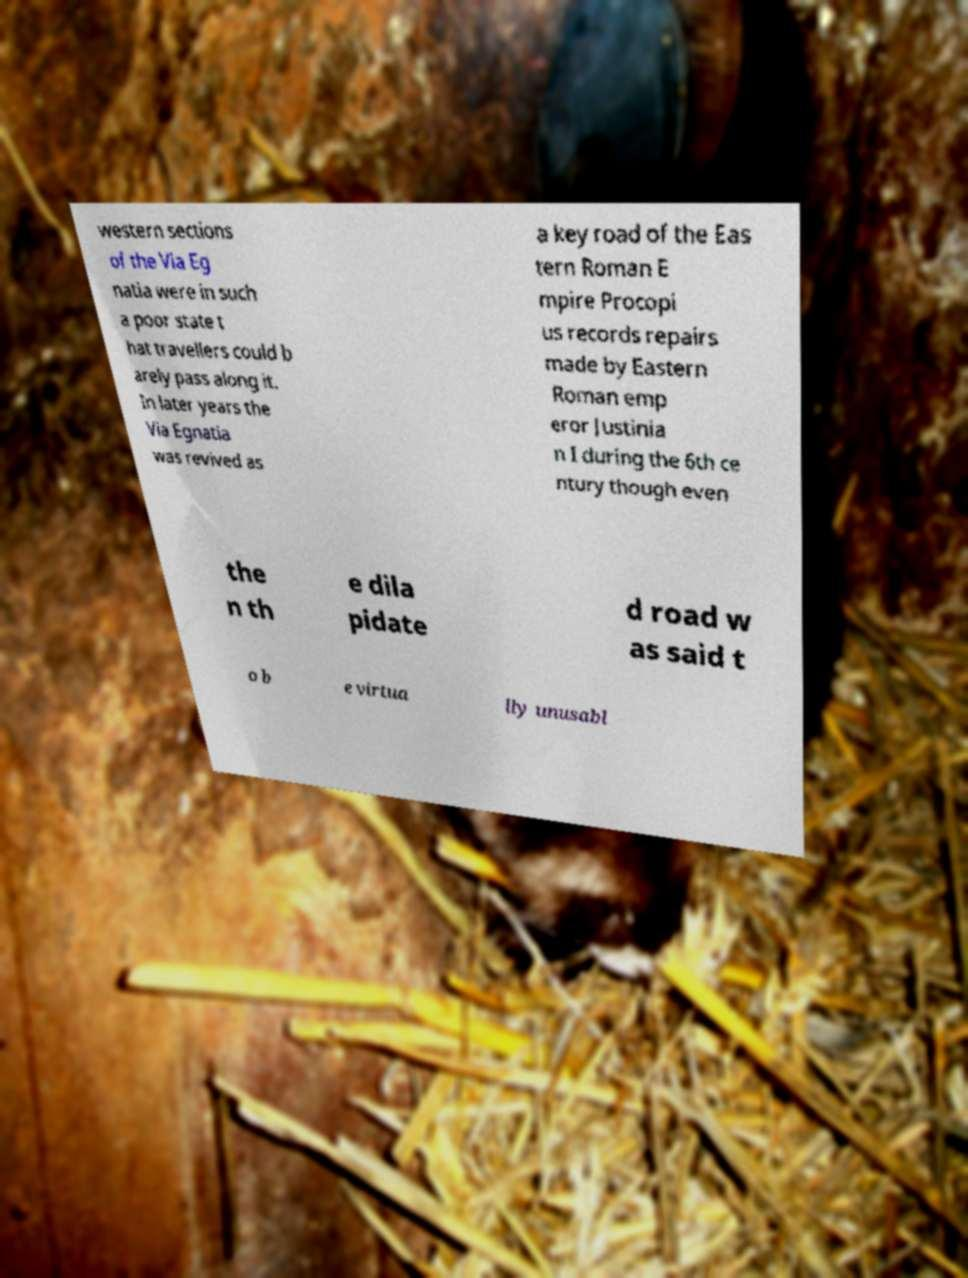Can you accurately transcribe the text from the provided image for me? western sections of the Via Eg natia were in such a poor state t hat travellers could b arely pass along it. In later years the Via Egnatia was revived as a key road of the Eas tern Roman E mpire Procopi us records repairs made by Eastern Roman emp eror Justinia n I during the 6th ce ntury though even the n th e dila pidate d road w as said t o b e virtua lly unusabl 